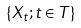Convert formula to latex. <formula><loc_0><loc_0><loc_500><loc_500>\{ X _ { t } ; t \in T \}</formula> 